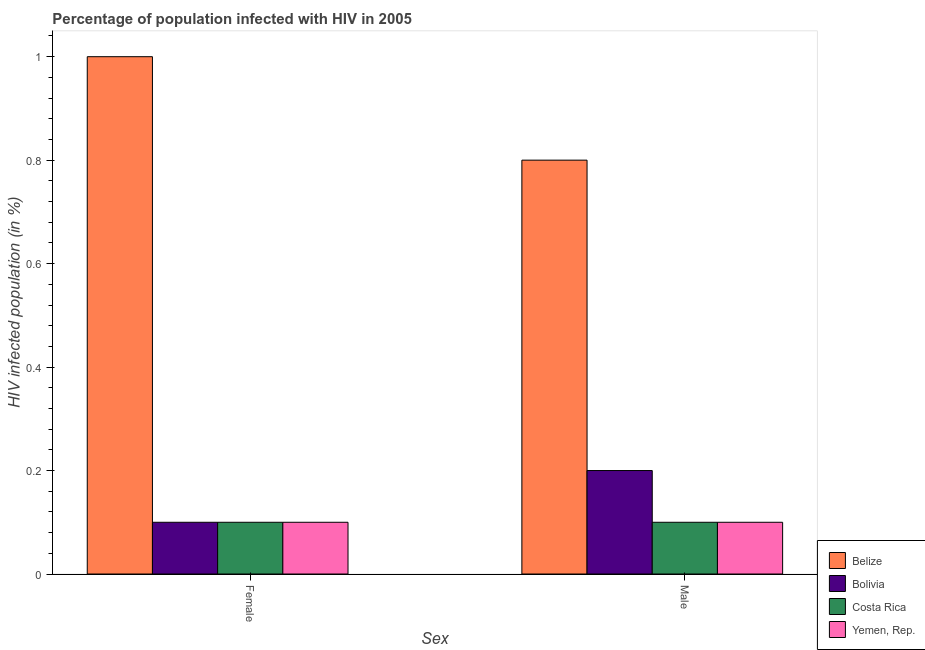How many different coloured bars are there?
Give a very brief answer. 4. Are the number of bars per tick equal to the number of legend labels?
Offer a terse response. Yes. What is the label of the 2nd group of bars from the left?
Your response must be concise. Male. Across all countries, what is the maximum percentage of males who are infected with hiv?
Your answer should be very brief. 0.8. Across all countries, what is the minimum percentage of females who are infected with hiv?
Provide a short and direct response. 0.1. In which country was the percentage of females who are infected with hiv maximum?
Your response must be concise. Belize. What is the total percentage of males who are infected with hiv in the graph?
Keep it short and to the point. 1.2. What is the average percentage of males who are infected with hiv per country?
Provide a short and direct response. 0.3. What is the difference between the percentage of females who are infected with hiv and percentage of males who are infected with hiv in Bolivia?
Your answer should be very brief. -0.1. In how many countries, is the percentage of males who are infected with hiv greater than 0.7600000000000001 %?
Offer a very short reply. 1. In how many countries, is the percentage of males who are infected with hiv greater than the average percentage of males who are infected with hiv taken over all countries?
Provide a succinct answer. 1. How many bars are there?
Your answer should be compact. 8. What is the difference between two consecutive major ticks on the Y-axis?
Provide a short and direct response. 0.2. Does the graph contain any zero values?
Your answer should be very brief. No. How many legend labels are there?
Offer a terse response. 4. How are the legend labels stacked?
Keep it short and to the point. Vertical. What is the title of the graph?
Make the answer very short. Percentage of population infected with HIV in 2005. Does "Mauritius" appear as one of the legend labels in the graph?
Provide a succinct answer. No. What is the label or title of the X-axis?
Make the answer very short. Sex. What is the label or title of the Y-axis?
Offer a very short reply. HIV infected population (in %). What is the HIV infected population (in %) of Bolivia in Female?
Offer a very short reply. 0.1. What is the HIV infected population (in %) of Bolivia in Male?
Offer a very short reply. 0.2. What is the HIV infected population (in %) of Costa Rica in Male?
Your answer should be very brief. 0.1. Across all Sex, what is the maximum HIV infected population (in %) of Belize?
Your response must be concise. 1. Across all Sex, what is the maximum HIV infected population (in %) in Costa Rica?
Offer a terse response. 0.1. Across all Sex, what is the minimum HIV infected population (in %) of Belize?
Keep it short and to the point. 0.8. Across all Sex, what is the minimum HIV infected population (in %) in Bolivia?
Make the answer very short. 0.1. What is the total HIV infected population (in %) of Bolivia in the graph?
Make the answer very short. 0.3. What is the total HIV infected population (in %) in Costa Rica in the graph?
Your answer should be very brief. 0.2. What is the difference between the HIV infected population (in %) of Belize in Female and that in Male?
Your answer should be very brief. 0.2. What is the difference between the HIV infected population (in %) of Yemen, Rep. in Female and that in Male?
Keep it short and to the point. 0. What is the difference between the HIV infected population (in %) in Bolivia in Female and the HIV infected population (in %) in Yemen, Rep. in Male?
Give a very brief answer. 0. What is the difference between the HIV infected population (in %) in Costa Rica in Female and the HIV infected population (in %) in Yemen, Rep. in Male?
Give a very brief answer. 0. What is the average HIV infected population (in %) in Belize per Sex?
Keep it short and to the point. 0.9. What is the difference between the HIV infected population (in %) in Belize and HIV infected population (in %) in Bolivia in Female?
Your response must be concise. 0.9. What is the difference between the HIV infected population (in %) in Belize and HIV infected population (in %) in Yemen, Rep. in Female?
Your response must be concise. 0.9. What is the difference between the HIV infected population (in %) in Belize and HIV infected population (in %) in Costa Rica in Male?
Offer a very short reply. 0.7. What is the difference between the HIV infected population (in %) of Belize and HIV infected population (in %) of Yemen, Rep. in Male?
Provide a short and direct response. 0.7. What is the ratio of the HIV infected population (in %) in Belize in Female to that in Male?
Give a very brief answer. 1.25. What is the ratio of the HIV infected population (in %) in Bolivia in Female to that in Male?
Ensure brevity in your answer.  0.5. What is the ratio of the HIV infected population (in %) of Costa Rica in Female to that in Male?
Your response must be concise. 1. What is the ratio of the HIV infected population (in %) of Yemen, Rep. in Female to that in Male?
Your response must be concise. 1. What is the difference between the highest and the second highest HIV infected population (in %) of Costa Rica?
Your answer should be very brief. 0. What is the difference between the highest and the lowest HIV infected population (in %) of Belize?
Your answer should be compact. 0.2. What is the difference between the highest and the lowest HIV infected population (in %) in Bolivia?
Your answer should be compact. 0.1. What is the difference between the highest and the lowest HIV infected population (in %) of Costa Rica?
Make the answer very short. 0. What is the difference between the highest and the lowest HIV infected population (in %) in Yemen, Rep.?
Your response must be concise. 0. 